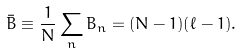<formula> <loc_0><loc_0><loc_500><loc_500>\bar { B } \equiv \frac { 1 } { N } \sum _ { n } B _ { n } = ( N - 1 ) ( \ell - 1 ) .</formula> 